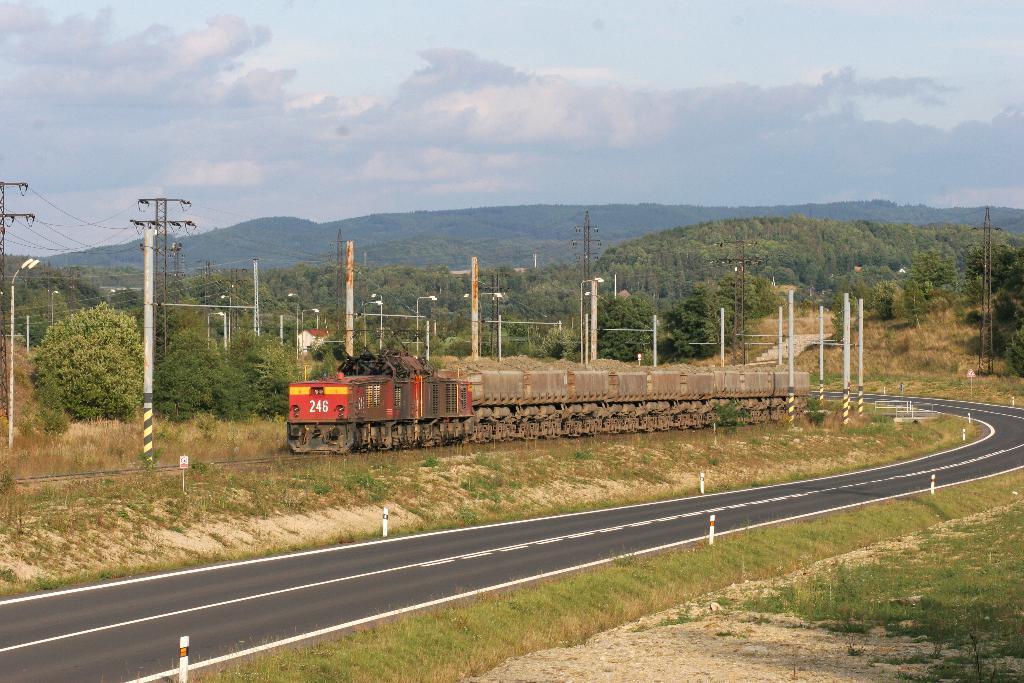How would you summarize this image in a sentence or two? This picture is taken outside a city. In the foreground of the picture there are shrubs, grass, soil, road and poles. In the center of the picture there are poles, cables, street lights, trees, railway track and train. In the background there are hills covered with trees. It is sunny. 